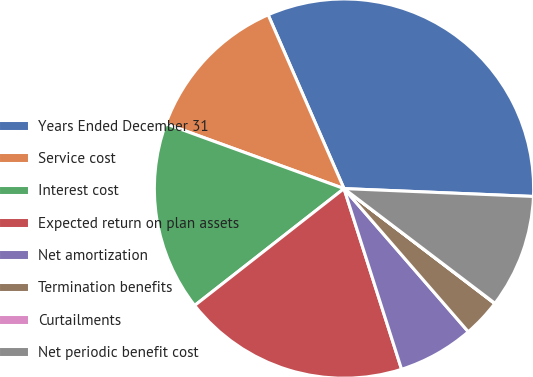<chart> <loc_0><loc_0><loc_500><loc_500><pie_chart><fcel>Years Ended December 31<fcel>Service cost<fcel>Interest cost<fcel>Expected return on plan assets<fcel>Net amortization<fcel>Termination benefits<fcel>Curtailments<fcel>Net periodic benefit cost<nl><fcel>32.21%<fcel>12.9%<fcel>16.12%<fcel>19.34%<fcel>6.47%<fcel>3.25%<fcel>0.03%<fcel>9.68%<nl></chart> 